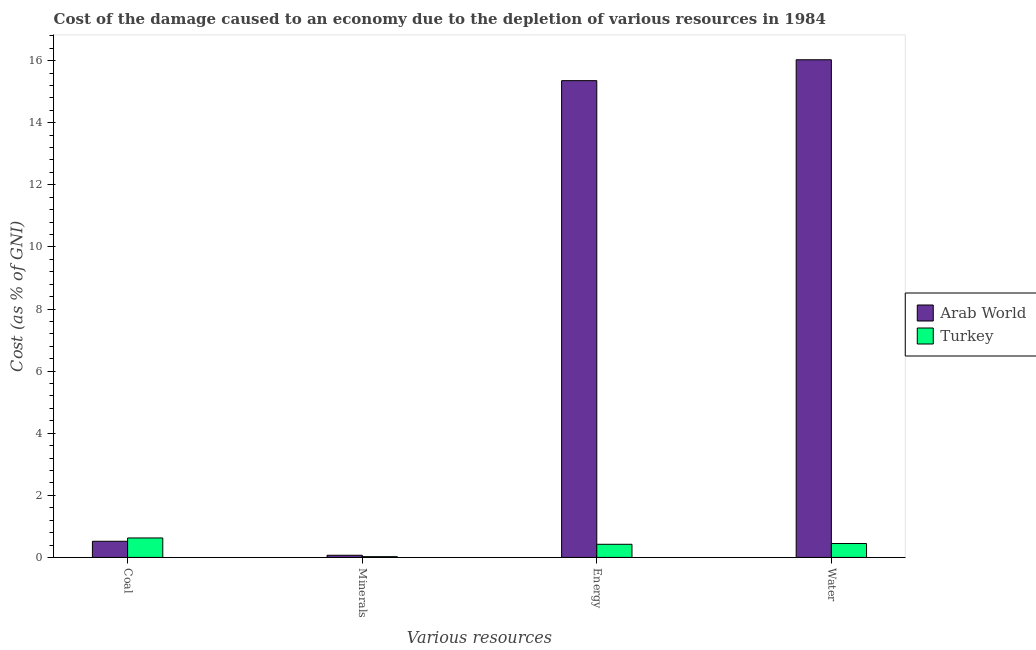How many groups of bars are there?
Provide a succinct answer. 4. Are the number of bars per tick equal to the number of legend labels?
Your response must be concise. Yes. How many bars are there on the 4th tick from the right?
Offer a very short reply. 2. What is the label of the 4th group of bars from the left?
Offer a terse response. Water. What is the cost of damage due to depletion of energy in Turkey?
Your answer should be compact. 0.42. Across all countries, what is the maximum cost of damage due to depletion of coal?
Your answer should be compact. 0.63. Across all countries, what is the minimum cost of damage due to depletion of energy?
Your response must be concise. 0.42. In which country was the cost of damage due to depletion of energy maximum?
Your answer should be very brief. Arab World. What is the total cost of damage due to depletion of minerals in the graph?
Provide a succinct answer. 0.09. What is the difference between the cost of damage due to depletion of coal in Arab World and that in Turkey?
Your answer should be compact. -0.11. What is the difference between the cost of damage due to depletion of coal in Turkey and the cost of damage due to depletion of minerals in Arab World?
Provide a succinct answer. 0.56. What is the average cost of damage due to depletion of energy per country?
Your answer should be compact. 7.89. What is the difference between the cost of damage due to depletion of energy and cost of damage due to depletion of water in Arab World?
Your response must be concise. -0.67. What is the ratio of the cost of damage due to depletion of energy in Arab World to that in Turkey?
Ensure brevity in your answer.  36.29. Is the difference between the cost of damage due to depletion of minerals in Arab World and Turkey greater than the difference between the cost of damage due to depletion of water in Arab World and Turkey?
Offer a terse response. No. What is the difference between the highest and the second highest cost of damage due to depletion of coal?
Offer a very short reply. 0.11. What is the difference between the highest and the lowest cost of damage due to depletion of water?
Give a very brief answer. 15.58. Is it the case that in every country, the sum of the cost of damage due to depletion of water and cost of damage due to depletion of energy is greater than the sum of cost of damage due to depletion of coal and cost of damage due to depletion of minerals?
Your answer should be compact. No. What does the 2nd bar from the left in Minerals represents?
Make the answer very short. Turkey. What does the 2nd bar from the right in Coal represents?
Provide a succinct answer. Arab World. How many countries are there in the graph?
Make the answer very short. 2. What is the difference between two consecutive major ticks on the Y-axis?
Keep it short and to the point. 2. How many legend labels are there?
Your answer should be very brief. 2. What is the title of the graph?
Keep it short and to the point. Cost of the damage caused to an economy due to the depletion of various resources in 1984 . What is the label or title of the X-axis?
Make the answer very short. Various resources. What is the label or title of the Y-axis?
Make the answer very short. Cost (as % of GNI). What is the Cost (as % of GNI) of Arab World in Coal?
Your answer should be very brief. 0.52. What is the Cost (as % of GNI) in Turkey in Coal?
Your answer should be compact. 0.63. What is the Cost (as % of GNI) of Arab World in Minerals?
Keep it short and to the point. 0.07. What is the Cost (as % of GNI) of Turkey in Minerals?
Your answer should be compact. 0.02. What is the Cost (as % of GNI) of Arab World in Energy?
Your response must be concise. 15.36. What is the Cost (as % of GNI) of Turkey in Energy?
Your response must be concise. 0.42. What is the Cost (as % of GNI) in Arab World in Water?
Your answer should be compact. 16.03. What is the Cost (as % of GNI) in Turkey in Water?
Give a very brief answer. 0.45. Across all Various resources, what is the maximum Cost (as % of GNI) of Arab World?
Your answer should be compact. 16.03. Across all Various resources, what is the maximum Cost (as % of GNI) of Turkey?
Offer a terse response. 0.63. Across all Various resources, what is the minimum Cost (as % of GNI) of Arab World?
Make the answer very short. 0.07. Across all Various resources, what is the minimum Cost (as % of GNI) in Turkey?
Make the answer very short. 0.02. What is the total Cost (as % of GNI) in Arab World in the graph?
Offer a terse response. 31.97. What is the total Cost (as % of GNI) of Turkey in the graph?
Provide a short and direct response. 1.52. What is the difference between the Cost (as % of GNI) in Arab World in Coal and that in Minerals?
Your response must be concise. 0.45. What is the difference between the Cost (as % of GNI) of Turkey in Coal and that in Minerals?
Your answer should be very brief. 0.6. What is the difference between the Cost (as % of GNI) of Arab World in Coal and that in Energy?
Your answer should be very brief. -14.84. What is the difference between the Cost (as % of GNI) of Turkey in Coal and that in Energy?
Provide a succinct answer. 0.2. What is the difference between the Cost (as % of GNI) in Arab World in Coal and that in Water?
Your answer should be compact. -15.51. What is the difference between the Cost (as % of GNI) in Turkey in Coal and that in Water?
Offer a very short reply. 0.18. What is the difference between the Cost (as % of GNI) in Arab World in Minerals and that in Energy?
Offer a terse response. -15.29. What is the difference between the Cost (as % of GNI) in Turkey in Minerals and that in Energy?
Make the answer very short. -0.4. What is the difference between the Cost (as % of GNI) in Arab World in Minerals and that in Water?
Your response must be concise. -15.96. What is the difference between the Cost (as % of GNI) of Turkey in Minerals and that in Water?
Make the answer very short. -0.42. What is the difference between the Cost (as % of GNI) in Arab World in Energy and that in Water?
Provide a succinct answer. -0.67. What is the difference between the Cost (as % of GNI) of Turkey in Energy and that in Water?
Provide a succinct answer. -0.02. What is the difference between the Cost (as % of GNI) in Arab World in Coal and the Cost (as % of GNI) in Turkey in Minerals?
Make the answer very short. 0.5. What is the difference between the Cost (as % of GNI) of Arab World in Coal and the Cost (as % of GNI) of Turkey in Energy?
Keep it short and to the point. 0.1. What is the difference between the Cost (as % of GNI) of Arab World in Coal and the Cost (as % of GNI) of Turkey in Water?
Ensure brevity in your answer.  0.07. What is the difference between the Cost (as % of GNI) in Arab World in Minerals and the Cost (as % of GNI) in Turkey in Energy?
Your answer should be very brief. -0.35. What is the difference between the Cost (as % of GNI) of Arab World in Minerals and the Cost (as % of GNI) of Turkey in Water?
Your answer should be very brief. -0.38. What is the difference between the Cost (as % of GNI) of Arab World in Energy and the Cost (as % of GNI) of Turkey in Water?
Offer a very short reply. 14.91. What is the average Cost (as % of GNI) of Arab World per Various resources?
Keep it short and to the point. 7.99. What is the average Cost (as % of GNI) of Turkey per Various resources?
Your response must be concise. 0.38. What is the difference between the Cost (as % of GNI) in Arab World and Cost (as % of GNI) in Turkey in Coal?
Offer a very short reply. -0.11. What is the difference between the Cost (as % of GNI) in Arab World and Cost (as % of GNI) in Turkey in Minerals?
Provide a succinct answer. 0.04. What is the difference between the Cost (as % of GNI) in Arab World and Cost (as % of GNI) in Turkey in Energy?
Make the answer very short. 14.93. What is the difference between the Cost (as % of GNI) of Arab World and Cost (as % of GNI) of Turkey in Water?
Your answer should be compact. 15.58. What is the ratio of the Cost (as % of GNI) in Arab World in Coal to that in Minerals?
Keep it short and to the point. 7.52. What is the ratio of the Cost (as % of GNI) of Turkey in Coal to that in Minerals?
Offer a terse response. 25.31. What is the ratio of the Cost (as % of GNI) of Arab World in Coal to that in Energy?
Your response must be concise. 0.03. What is the ratio of the Cost (as % of GNI) of Turkey in Coal to that in Energy?
Keep it short and to the point. 1.48. What is the ratio of the Cost (as % of GNI) in Arab World in Coal to that in Water?
Provide a succinct answer. 0.03. What is the ratio of the Cost (as % of GNI) of Turkey in Coal to that in Water?
Your answer should be compact. 1.4. What is the ratio of the Cost (as % of GNI) of Arab World in Minerals to that in Energy?
Make the answer very short. 0. What is the ratio of the Cost (as % of GNI) of Turkey in Minerals to that in Energy?
Provide a short and direct response. 0.06. What is the ratio of the Cost (as % of GNI) in Arab World in Minerals to that in Water?
Your answer should be very brief. 0. What is the ratio of the Cost (as % of GNI) in Turkey in Minerals to that in Water?
Make the answer very short. 0.06. What is the ratio of the Cost (as % of GNI) of Arab World in Energy to that in Water?
Make the answer very short. 0.96. What is the ratio of the Cost (as % of GNI) in Turkey in Energy to that in Water?
Your answer should be very brief. 0.94. What is the difference between the highest and the second highest Cost (as % of GNI) of Arab World?
Your response must be concise. 0.67. What is the difference between the highest and the second highest Cost (as % of GNI) of Turkey?
Ensure brevity in your answer.  0.18. What is the difference between the highest and the lowest Cost (as % of GNI) in Arab World?
Keep it short and to the point. 15.96. What is the difference between the highest and the lowest Cost (as % of GNI) in Turkey?
Your answer should be very brief. 0.6. 